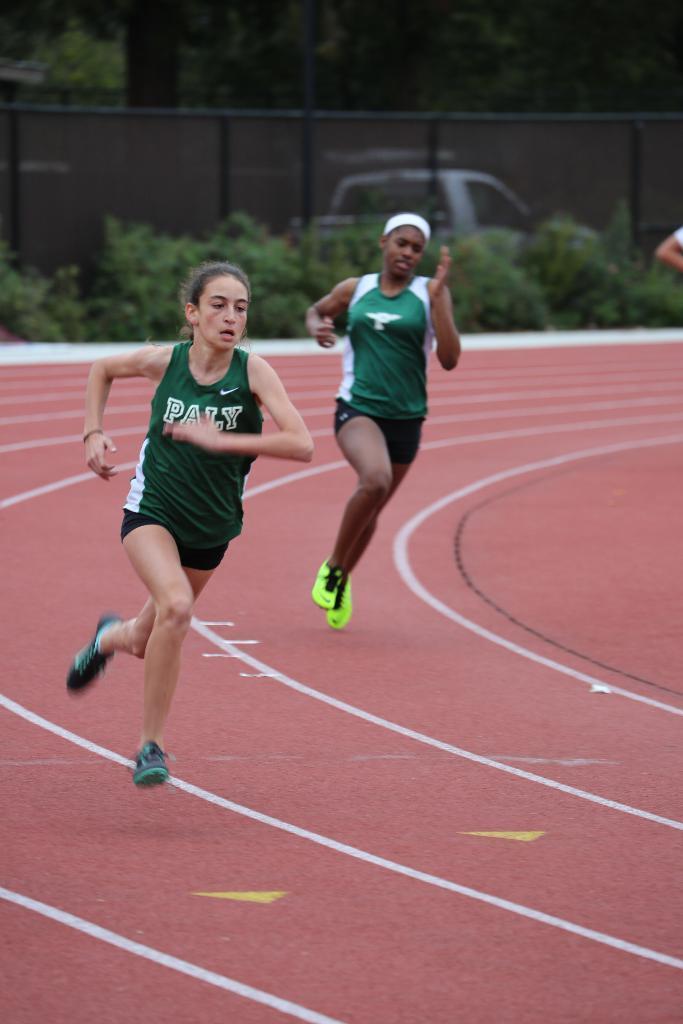Please provide a concise description of this image. In this image we can see two persons wearing green color dress and running in the court which is of pink color and in the background of the image there are some plants, fencing and some trees. 